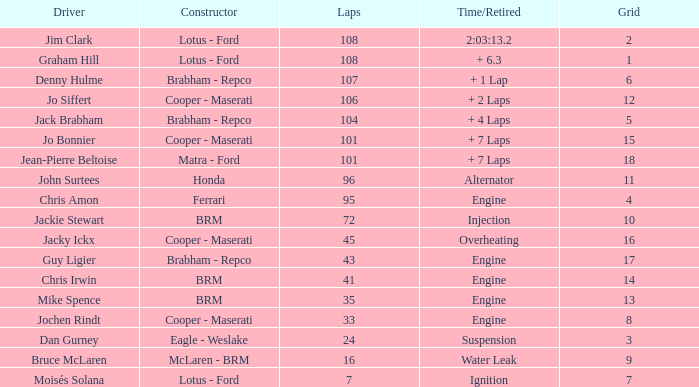What was the constructor when there were 95 laps and a grid less than 15? Ferrari. 